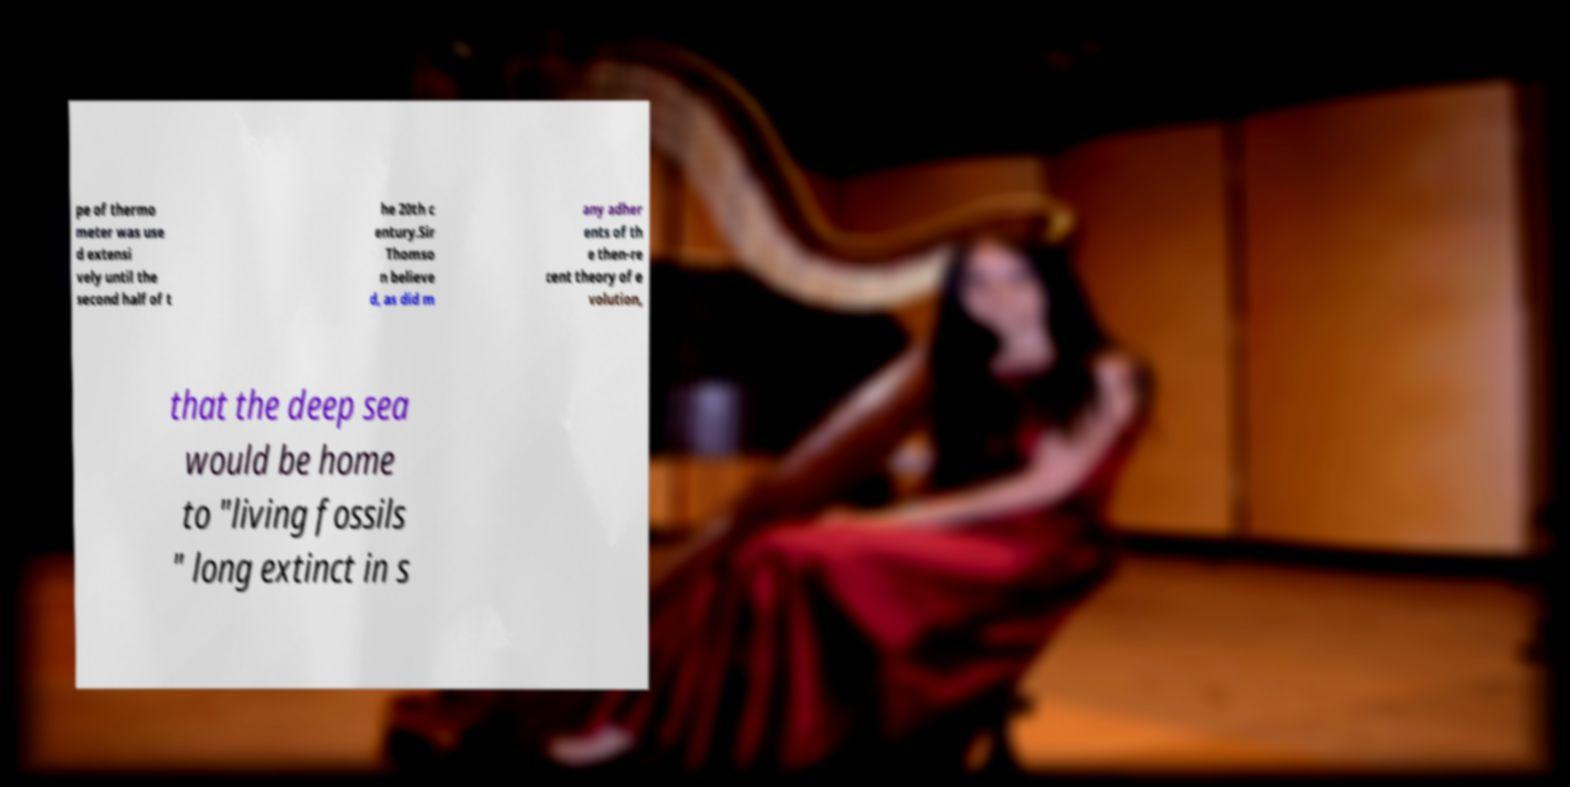Could you extract and type out the text from this image? pe of thermo meter was use d extensi vely until the second half of t he 20th c entury.Sir Thomso n believe d, as did m any adher ents of th e then-re cent theory of e volution, that the deep sea would be home to "living fossils " long extinct in s 